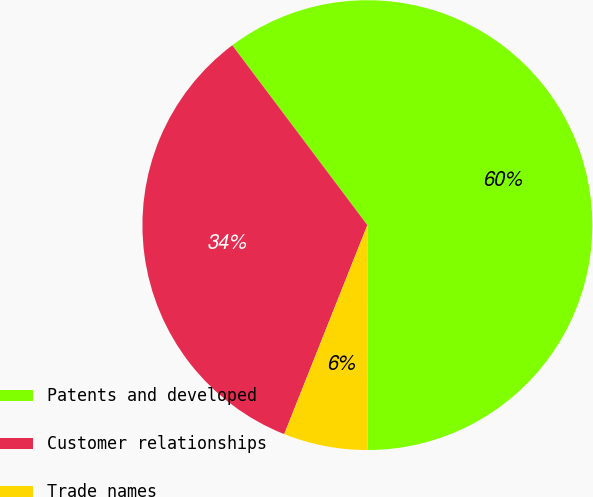<chart> <loc_0><loc_0><loc_500><loc_500><pie_chart><fcel>Patents and developed<fcel>Customer relationships<fcel>Trade names<nl><fcel>60.23%<fcel>33.72%<fcel>6.05%<nl></chart> 